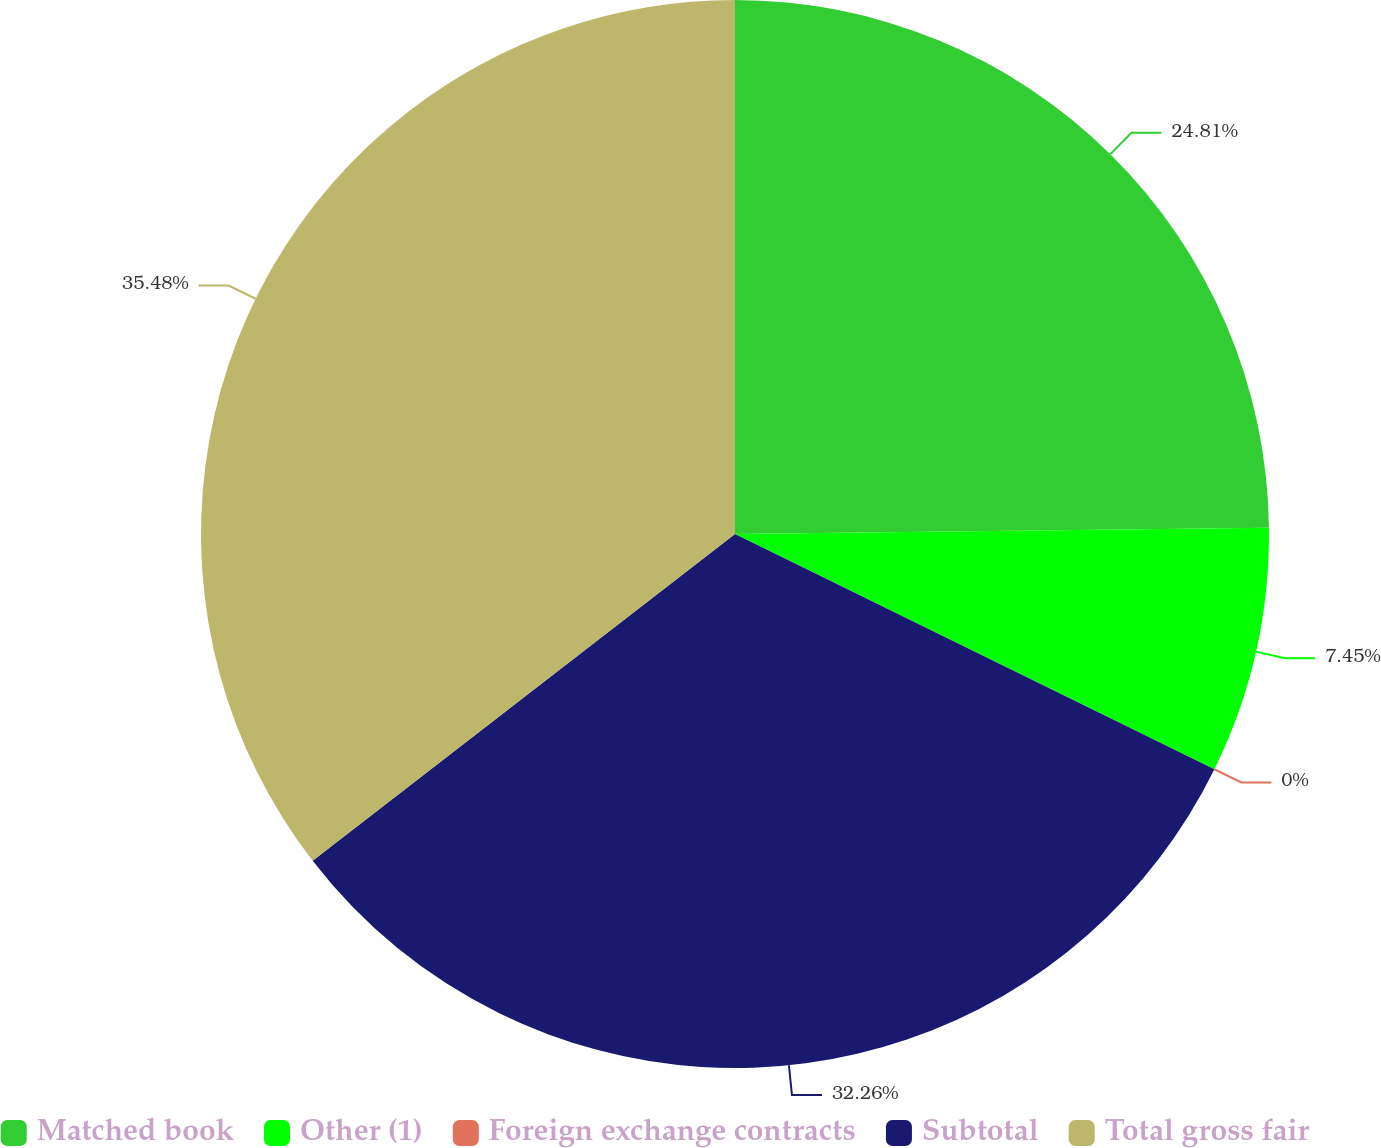Convert chart to OTSL. <chart><loc_0><loc_0><loc_500><loc_500><pie_chart><fcel>Matched book<fcel>Other (1)<fcel>Foreign exchange contracts<fcel>Subtotal<fcel>Total gross fair<nl><fcel>24.81%<fcel>7.45%<fcel>0.0%<fcel>32.26%<fcel>35.48%<nl></chart> 